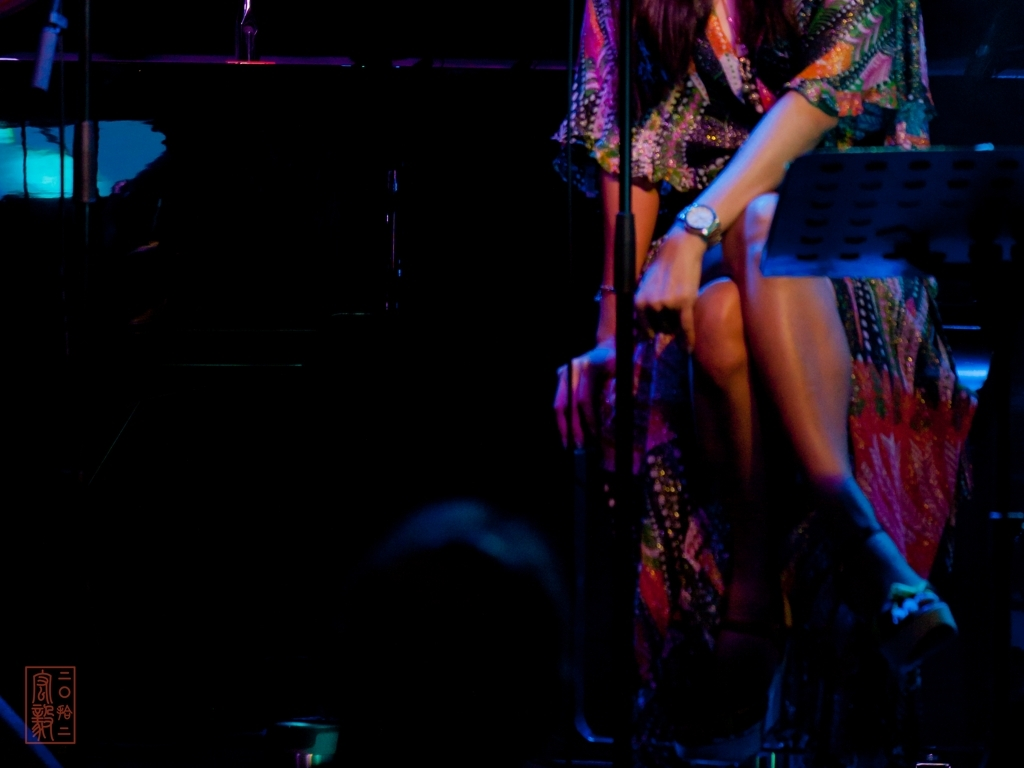Is the brightness of the image dim? The image indeed has a dim brightness, characterized by subdued lighting that creates a moody and intimate atmosphere often associated with live music venues or performances. 